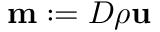<formula> <loc_0><loc_0><loc_500><loc_500>m \colon = D \rho u</formula> 